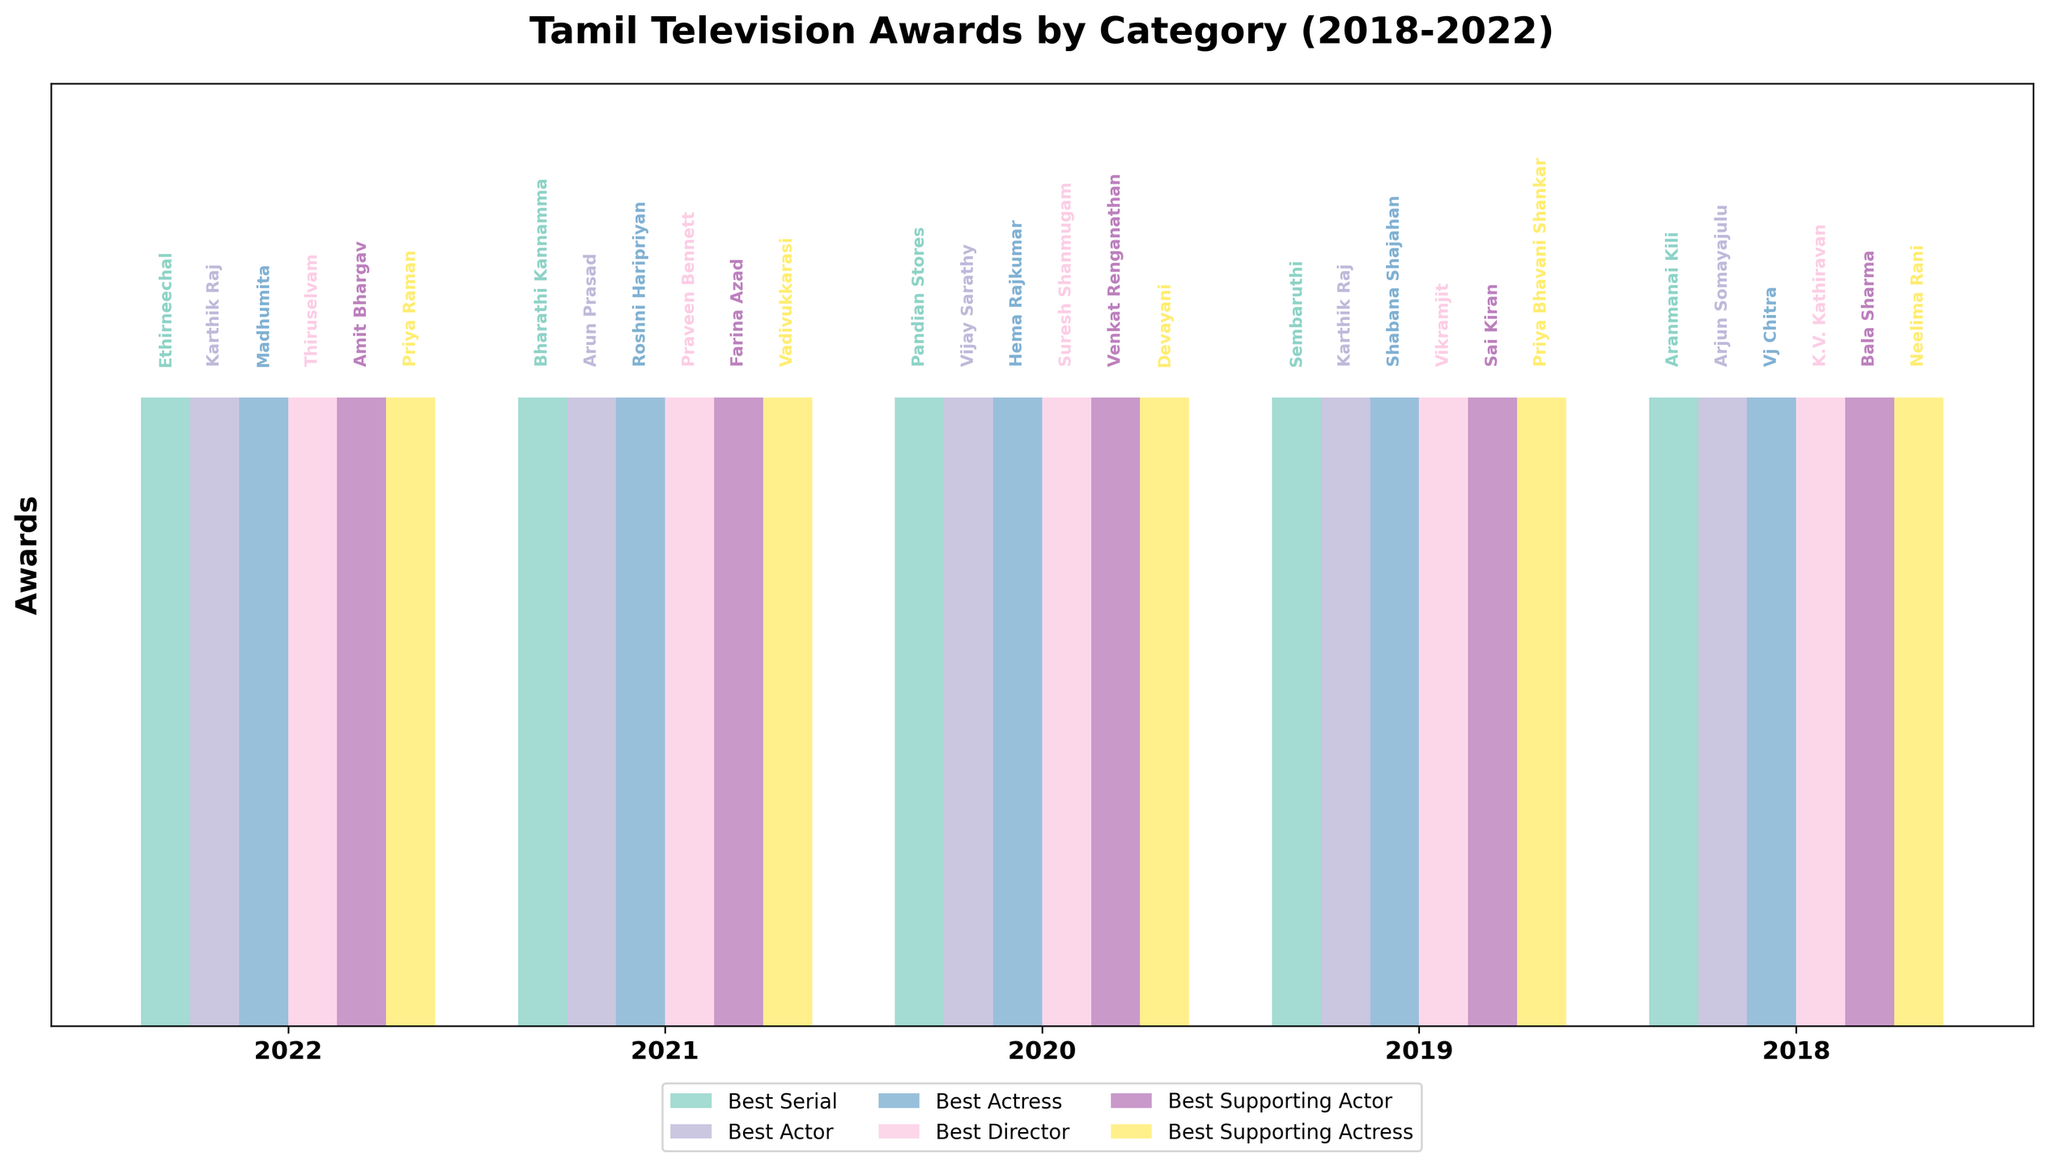Which serial won the 'Best Serial' award in 2019? By examining the bar representing the year 2019 and locating the bar corresponding to 'Best Serial', we see the text 'Sembaruthi'.
Answer: Sembaruthi Who won the 'Best Actress' award in 2021? By referring to the bar for the year 2021 and looking at the 'Best Actress' category, we see the name 'Roshni Haripriyan'.
Answer: Roshni Haripriyan How many times did Karthik Raj win 'Best Actor' in the given period? Karthik Raj won the 'Best Actor' award in 2019 and 2022. Counting these instances, we find he won 2 times.
Answer: 2 Which year had 'Aranmanai Kili' winning the 'Best Serial' award? By finding 'Aranmanai Kili' in the 'Best Serial' category, we see it is listed under the year 2018.
Answer: 2018 Who won the 'Best Supporting Actress' award in 2020? By examining the 2020 bar and looking at the 'Best Supporting Actress' category, we find the name 'Devayani'.
Answer: Devayani During which year did Suresh Shanmugam win an award, and in what category? By locating 'Suresh Shanmugam' in the text annotations, we find he won under 'Best Director' in the year 2020.
Answer: 2020, Best Director How many different actors won 'Best Supporting Actor' from 2018 to 2022? By examining each year's text for 'Best Supporting Actor', we find: Bala Sharma, Sai Kiran, Venkat Renganathan, Farina Azad, and Amit Bhargav, totaling 5 different actors.
Answer: 5 Compare the winners of 'Best Actor' and 'Best Actress' in 2019. Who won? The winners for 2019 are Karthik Raj (Best Actor) and Shabana Shajahan (Best Actress).
Answer: Karthik Raj, Shabana Shajahan Which category shows Vijay Sarathy as a winner and in which year? Vijay Sarathy can be found as the winner for the 'Best Actor' category in the year 2020.
Answer: Best Actor, 2020 Who won 'Best Director' in 2021 and how does it compare to the 'Best Serial' winner the same year? The 'Best Director' winner in 2021 is Praveen Bennett, while the 'Best Serial' winner the same year is 'Bharathi Kannamma'.
Answer: Praveen Bennett, Bharathi Kannamma 